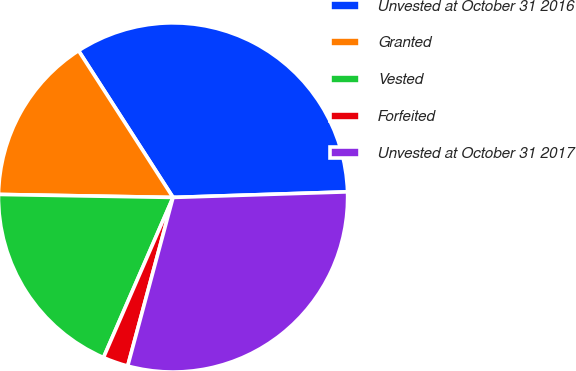<chart> <loc_0><loc_0><loc_500><loc_500><pie_chart><fcel>Unvested at October 31 2016<fcel>Granted<fcel>Vested<fcel>Forfeited<fcel>Unvested at October 31 2017<nl><fcel>33.59%<fcel>15.62%<fcel>18.75%<fcel>2.34%<fcel>29.69%<nl></chart> 